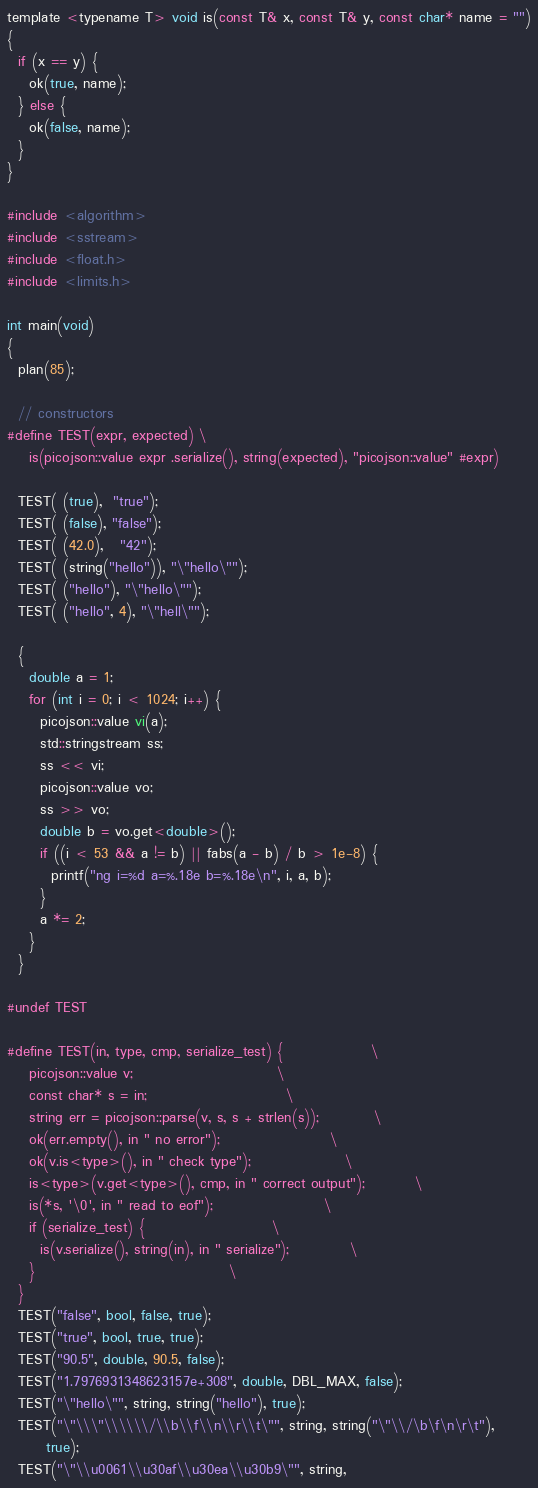<code> <loc_0><loc_0><loc_500><loc_500><_C_>template <typename T> void is(const T& x, const T& y, const char* name = "")
{
  if (x == y) {
    ok(true, name);
  } else {
    ok(false, name);
  }
}

#include <algorithm>
#include <sstream>
#include <float.h>
#include <limits.h>

int main(void)
{
  plan(85);

  // constructors
#define TEST(expr, expected) \
    is(picojson::value expr .serialize(), string(expected), "picojson::value" #expr)
  
  TEST( (true),  "true");
  TEST( (false), "false");
  TEST( (42.0),   "42");
  TEST( (string("hello")), "\"hello\"");
  TEST( ("hello"), "\"hello\"");
  TEST( ("hello", 4), "\"hell\"");

  {
    double a = 1;
    for (int i = 0; i < 1024; i++) {
      picojson::value vi(a);
      std::stringstream ss;
      ss << vi;
      picojson::value vo;
      ss >> vo;
      double b = vo.get<double>();
      if ((i < 53 && a != b) || fabs(a - b) / b > 1e-8) {
        printf("ng i=%d a=%.18e b=%.18e\n", i, a, b);
      }
      a *= 2;
    }
  }
  
#undef TEST
  
#define TEST(in, type, cmp, serialize_test) {				\
    picojson::value v;							\
    const char* s = in;							\
    string err = picojson::parse(v, s, s + strlen(s));			\
    ok(err.empty(), in " no error");					\
    ok(v.is<type>(), in " check type");					\
    is<type>(v.get<type>(), cmp, in " correct output");			\
    is(*s, '\0', in " read to eof");					\
    if (serialize_test) {						\
      is(v.serialize(), string(in), in " serialize");			\
    }									\
  }
  TEST("false", bool, false, true);
  TEST("true", bool, true, true);
  TEST("90.5", double, 90.5, false);
  TEST("1.7976931348623157e+308", double, DBL_MAX, false);
  TEST("\"hello\"", string, string("hello"), true);
  TEST("\"\\\"\\\\\\/\\b\\f\\n\\r\\t\"", string, string("\"\\/\b\f\n\r\t"),
       true);
  TEST("\"\\u0061\\u30af\\u30ea\\u30b9\"", string,</code> 